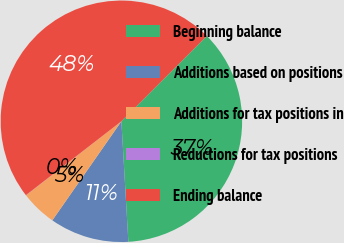<chart> <loc_0><loc_0><loc_500><loc_500><pie_chart><fcel>Beginning balance<fcel>Additions based on positions<fcel>Additions for tax positions in<fcel>Reductions for tax positions<fcel>Ending balance<nl><fcel>36.57%<fcel>10.61%<fcel>4.81%<fcel>0.02%<fcel>47.99%<nl></chart> 